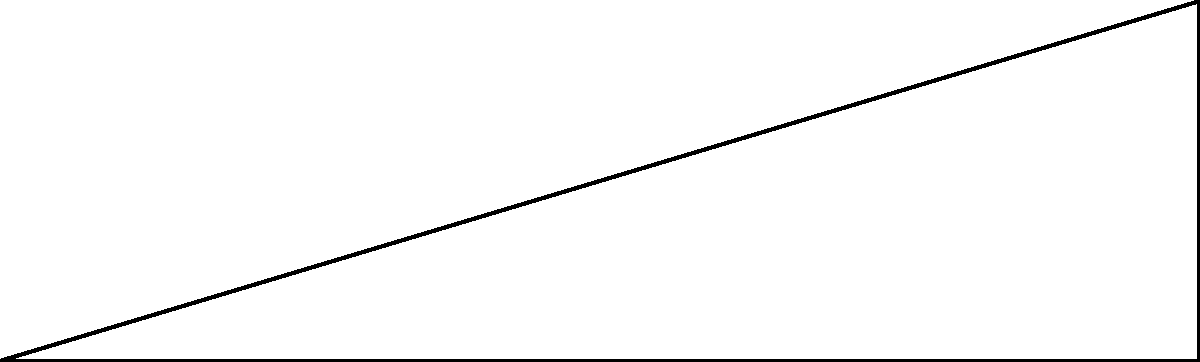In Kearney Park, you're admiring a historic building from a distance. You're standing 30 meters away from the base of the building, which is 9 meters tall. What is the angle of elevation (θ) to the top of the building from your position? To solve this problem, we'll use trigonometry, specifically the tangent function. Let's approach this step-by-step:

1) We have a right triangle where:
   - The adjacent side (ground distance) is 30 meters
   - The opposite side (building height) is 9 meters
   - We need to find the angle θ

2) The tangent of an angle in a right triangle is the ratio of the opposite side to the adjacent side:

   $\tan(\theta) = \frac{\text{opposite}}{\text{adjacent}} = \frac{\text{height}}{\text{distance}}$

3) Plugging in our values:

   $\tan(\theta) = \frac{9}{30} = \frac{3}{10} = 0.3$

4) To find θ, we need to use the inverse tangent (arctan or tan^(-1)):

   $\theta = \tan^{-1}(0.3)$

5) Using a calculator or trigonometric tables:

   $\theta \approx 16.70^\circ$

Therefore, the angle of elevation to the top of the historic building is approximately 16.70°.
Answer: $16.70^\circ$ 